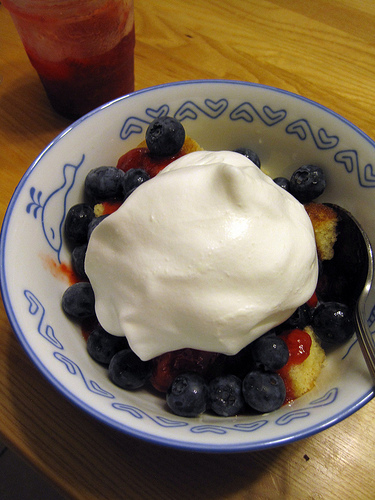<image>
Can you confirm if the whipped cream is next to the berries? No. The whipped cream is not positioned next to the berries. They are located in different areas of the scene. Is the blueberries in the bowl? Yes. The blueberries is contained within or inside the bowl, showing a containment relationship. 